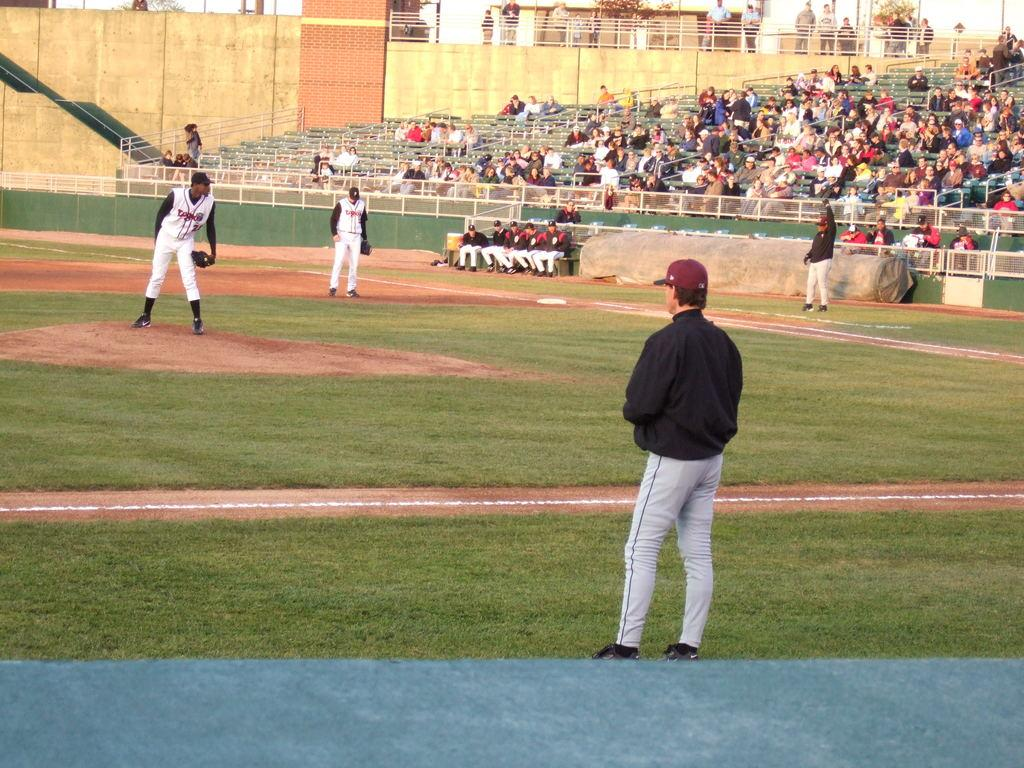How many people are standing on the ground in the image? There are four persons standing on the ground in the image. Can you describe the background of the image? In the background, there are people, rods, seats, walls, a brick wall, a rod railing, trees, and other objects visible. What type of structure might the rods and seats be a part of? The rods and seats in the background could be part of a seating area or a structure like a stadium or amphitheater. What type of wall is present in the background? There is a brick wall in the background. What type of vegetation can be seen in the background? Trees can be seen in the background. What type of cork is visible on the ground in the image? There is no cork visible on the ground in the image. What type of dress is the person in the background wearing? There is no person in the background wearing a dress, as the image only shows people standing on the ground and objects in the background. 